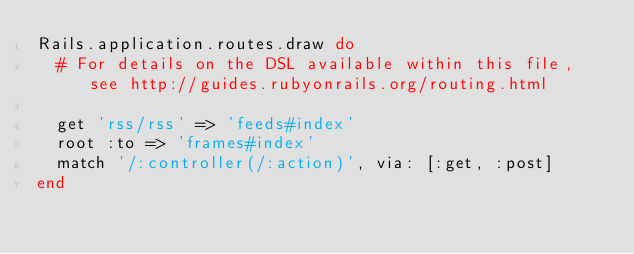Convert code to text. <code><loc_0><loc_0><loc_500><loc_500><_Ruby_>Rails.application.routes.draw do
  # For details on the DSL available within this file, see http://guides.rubyonrails.org/routing.html

  get 'rss/rss' => 'feeds#index'
  root :to => 'frames#index'
  match '/:controller(/:action)', via: [:get, :post]
end
</code> 